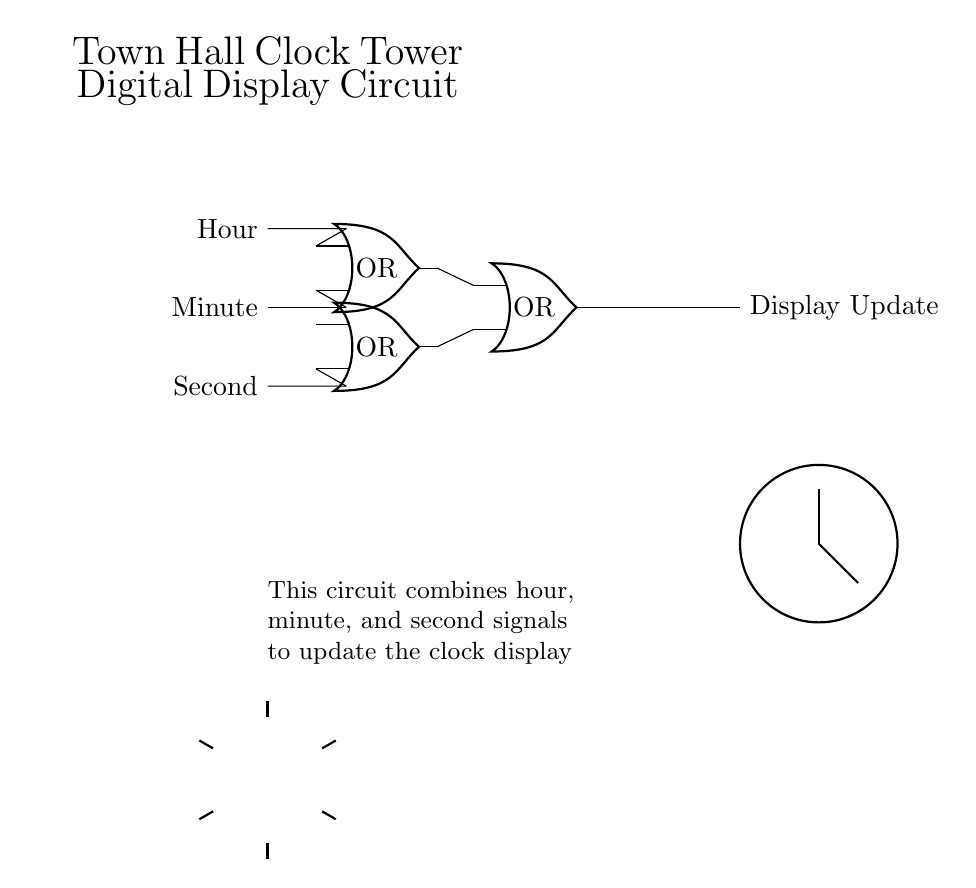What are the inputs of the OR gates? The inputs to the OR gates are Hour, Minute, and Second signals. Hour connects to the first OR gate, Minute connects to the second OR gate, and Second connects to the second OR gate as well.
Answer: Hour, Minute, Second How many OR gates are in the circuit? The circuit contains three OR gates, with two OR gates for combining signals before the final OR gate that updates the display.
Answer: Three What is the output of the last OR gate? The output of the last OR gate is used for the Display Update, which indicates that it combines the results of the previous signals.
Answer: Display Update Which signals combine into the final OR gate? The signals Hour and Minute combine into the first OR gate, while Minute and Second combine into the second OR gate, which feed into the third OR gate.
Answer: Hour and Minute; Minute and Second How does the clock signal affect the display? The clock signal affects the display by ensuring that the display is updated based on the Hour, Minute, and Second inputs, which are processed by the OR gates to provide the final output for the display update.
Answer: Updates display 